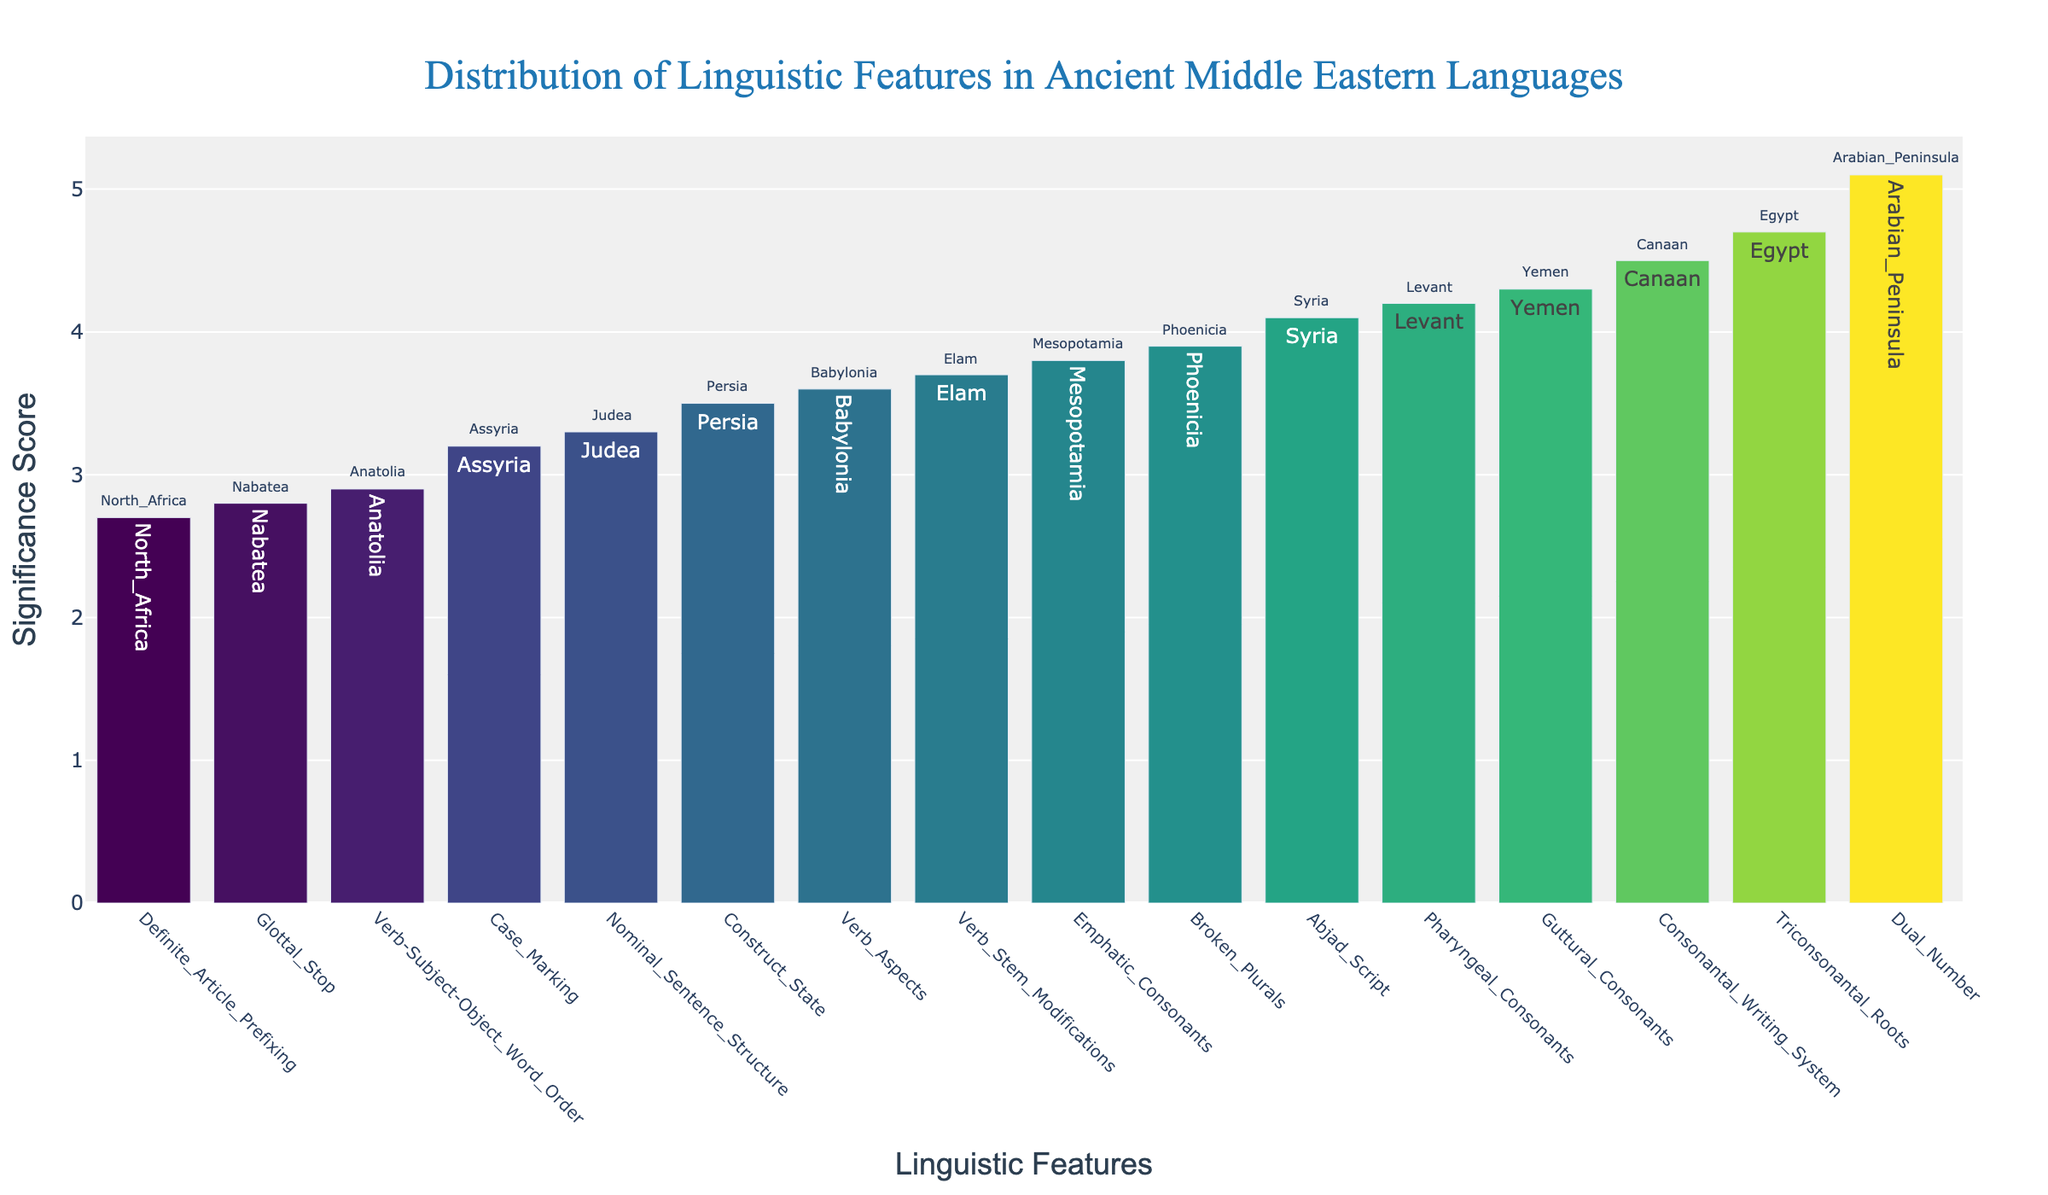What is the title of the figure? The title is typically located at the top of the figure, usually centered. In this case, it is the largest and in a different font compared to other texts.
Answer: Distribution of Linguistic Features in Ancient Middle Eastern Languages Which linguistic feature has the highest significance score? The bar with the highest value on the y-axis represents the most significant feature. The tallest bar corresponds to "Dual Number" with a significance score of 5.1.
Answer: Dual Number How many linguistic features have a significance score above 4.0? Observing the height of the bars, count the number of bars that extend above the 4.0 mark on the y-axis. There are 6 such features.
Answer: 6 Which linguistic feature associated with Egypt? Each bar has a text label that mentions its geographical location. The bar labeled 'Egypt' corresponds to "Triconsonantal Roots".
Answer: Triconsonantal Roots What is the difference in significance score between the highest and lowest linguistic features? The highest score is 5.1 (Dual Number) and the lowest score is 2.7 (Definite Article Prefixing). Subtract the lowest from the highest to get the difference. 5.1 - 2.7 = 2.4.
Answer: 2.4 Which geographical location appears on the bar with the fifth highest significance score? Sorting the bars by height from highest to lowest, the fifth highest bar corresponds to "Consonantal Writing System" with a score of 4.5, associated with Canaan.
Answer: Canaan Compare the significance scores of "Guttural Consonants" and "Broken Plurals". Which one is higher? Both features' scores are displayed by their respective bars. "Guttural Consonants" has a score of 4.3, whereas "Broken Plurals" has a score of 3.9. Therefore, "Guttural Consonants" is higher.
Answer: Guttural Consonants What is the average significance score of the linguistic features associated with Levant and Anatolia? The significance scores of the linguistic features for Levant and Anatolia are 4.2 and 2.9 respectively. Average these values: (4.2 + 2.9) / 2 = 3.55.
Answer: 3.55 Which linguistic feature lies between Phoenicia and Persia in terms of significance score? Functionally identifying the values, "Verb Stem Modifications" (Elam) lies between "Broken Plurals" (Phoenicia, 3.9) and "Construct State" (Persia, 3.5), with a score of 3.7.
Answer: Verb Stem Modifications What is the lowest subject-verb-object word order and its significance score? The linguistic feature with word order is "Verb-Subject-Object Word Order" which corresponds to Anatolia, with a significance score of 2.9.
Answer: 2.9 